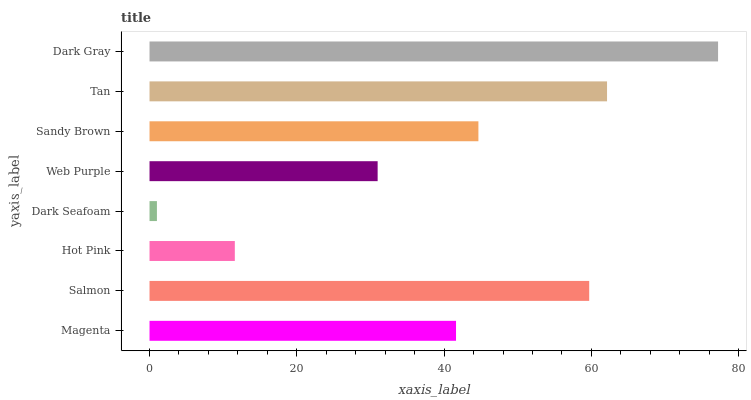Is Dark Seafoam the minimum?
Answer yes or no. Yes. Is Dark Gray the maximum?
Answer yes or no. Yes. Is Salmon the minimum?
Answer yes or no. No. Is Salmon the maximum?
Answer yes or no. No. Is Salmon greater than Magenta?
Answer yes or no. Yes. Is Magenta less than Salmon?
Answer yes or no. Yes. Is Magenta greater than Salmon?
Answer yes or no. No. Is Salmon less than Magenta?
Answer yes or no. No. Is Sandy Brown the high median?
Answer yes or no. Yes. Is Magenta the low median?
Answer yes or no. Yes. Is Tan the high median?
Answer yes or no. No. Is Sandy Brown the low median?
Answer yes or no. No. 